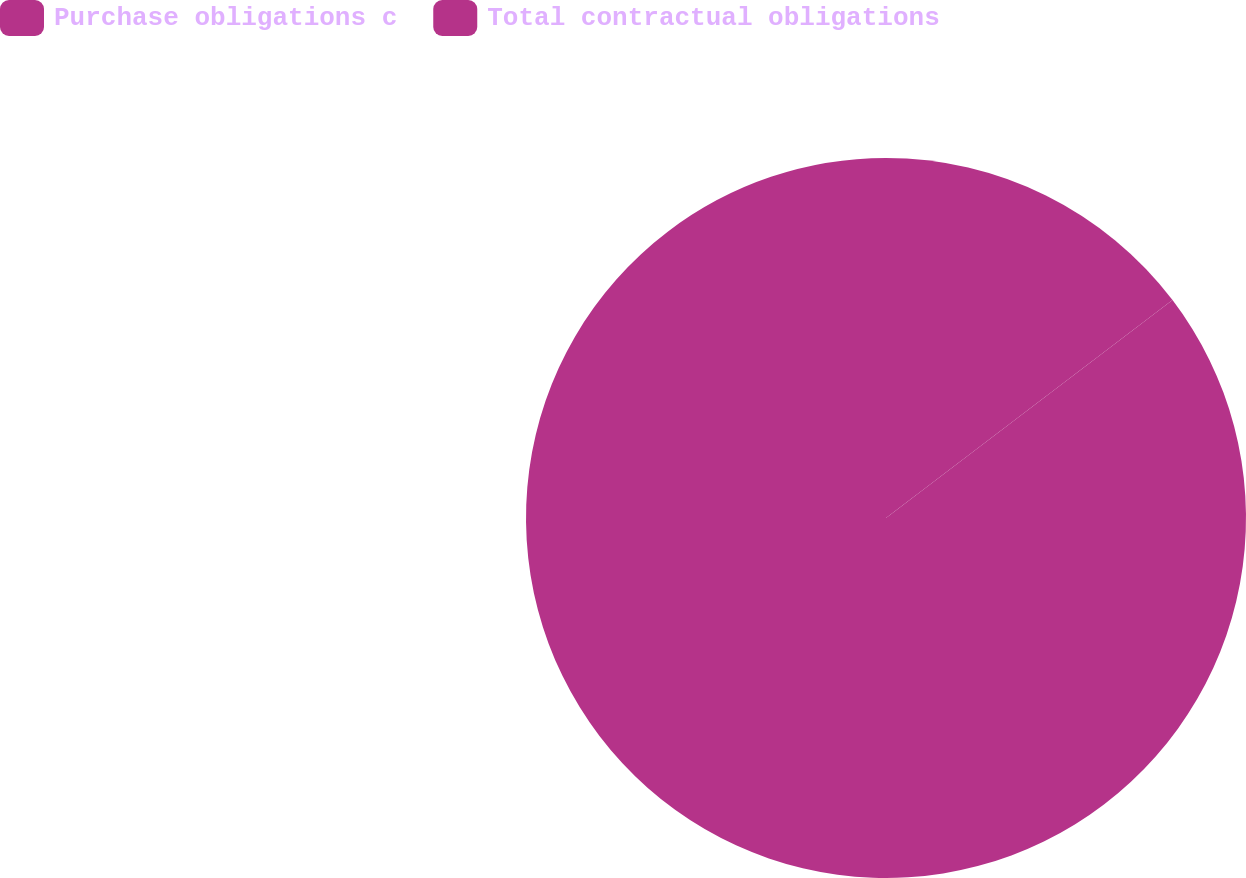Convert chart to OTSL. <chart><loc_0><loc_0><loc_500><loc_500><pie_chart><fcel>Purchase obligations c<fcel>Total contractual obligations<nl><fcel>14.65%<fcel>85.35%<nl></chart> 